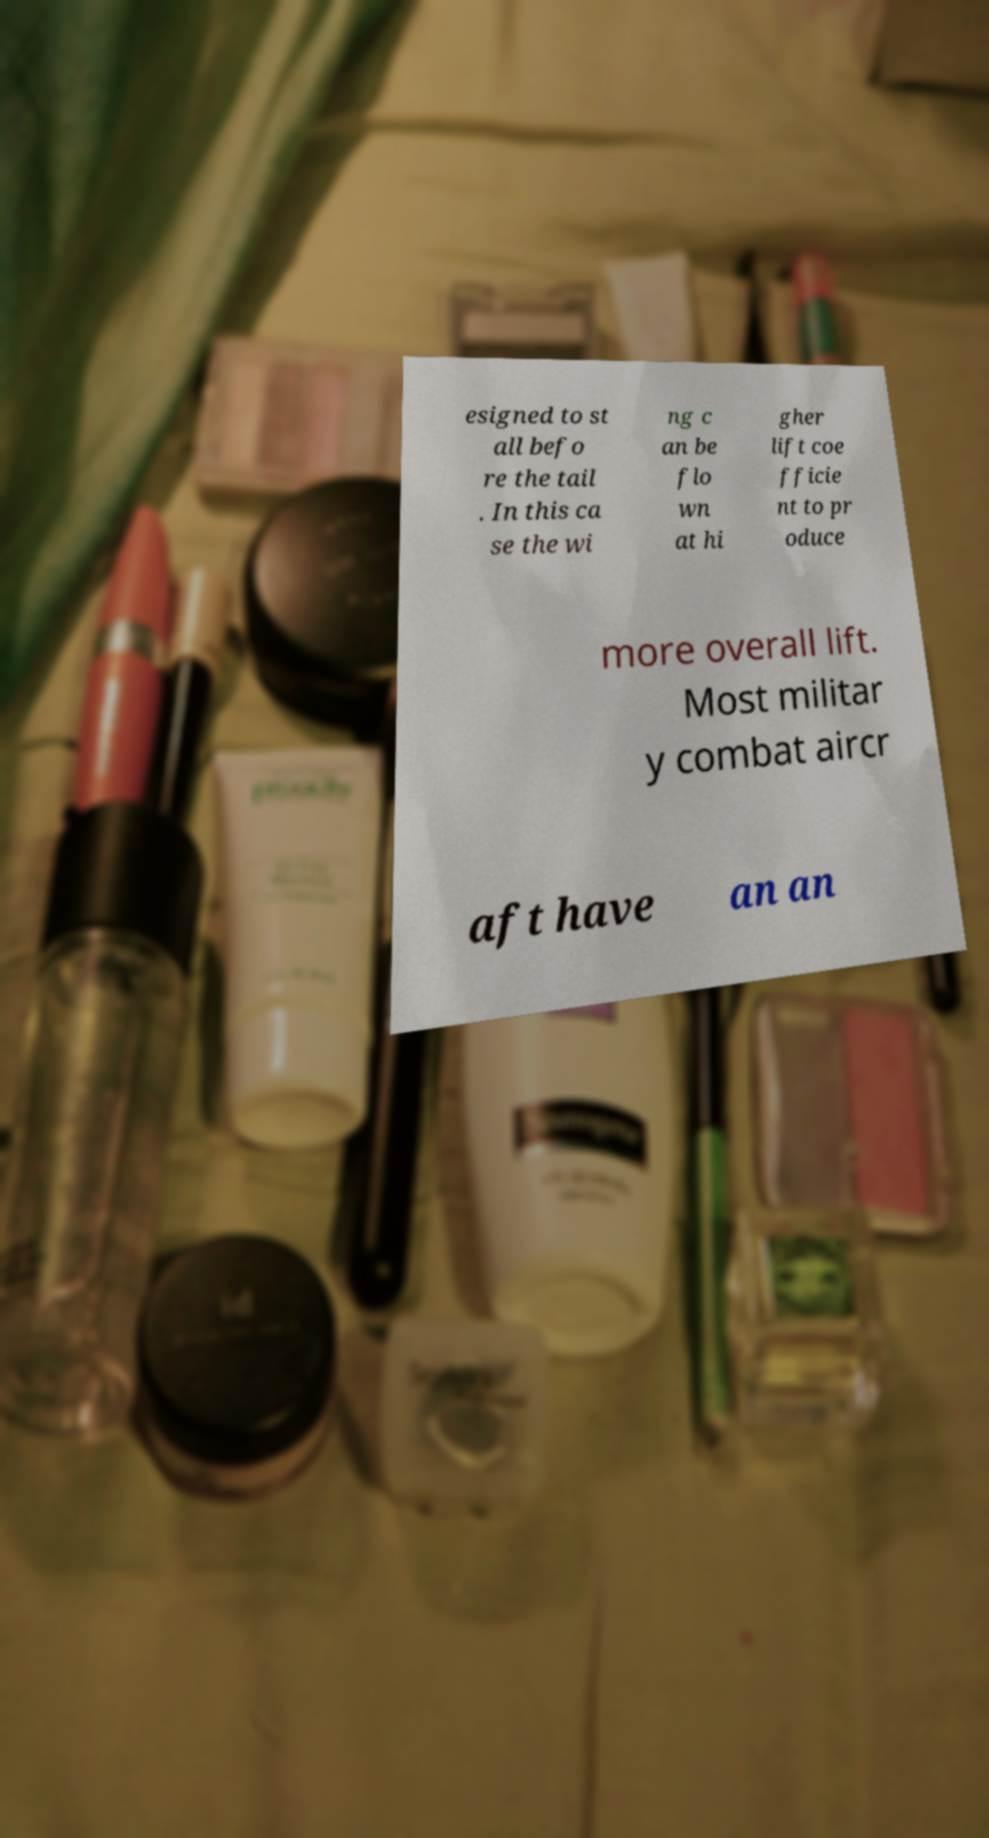What messages or text are displayed in this image? I need them in a readable, typed format. esigned to st all befo re the tail . In this ca se the wi ng c an be flo wn at hi gher lift coe fficie nt to pr oduce more overall lift. Most militar y combat aircr aft have an an 